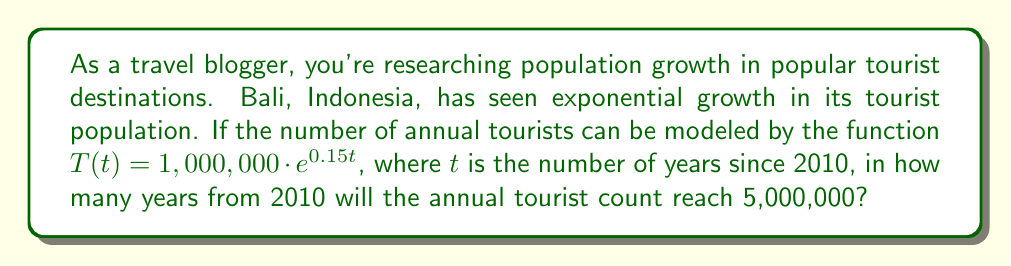Show me your answer to this math problem. Let's approach this step-by-step:

1) We're given the function $T(t) = 1,000,000 \cdot e^{0.15t}$, where $T$ is the number of tourists and $t$ is the number of years since 2010.

2) We want to find when $T(t) = 5,000,000$. So, let's set up the equation:

   $5,000,000 = 1,000,000 \cdot e^{0.15t}$

3) Divide both sides by 1,000,000:

   $5 = e^{0.15t}$

4) Take the natural logarithm of both sides:

   $\ln(5) = \ln(e^{0.15t})$

5) Simplify the right side using the logarithm property $\ln(e^x) = x$:

   $\ln(5) = 0.15t$

6) Solve for $t$ by dividing both sides by 0.15:

   $t = \frac{\ln(5)}{0.15}$

7) Calculate the result:

   $t \approx 10.65$ years

8) Since we're looking for a whole number of years, we round up to 11 years.

This means the tourist count will reach 5,000,000 in 2021 (11 years after 2010).
Answer: 11 years 